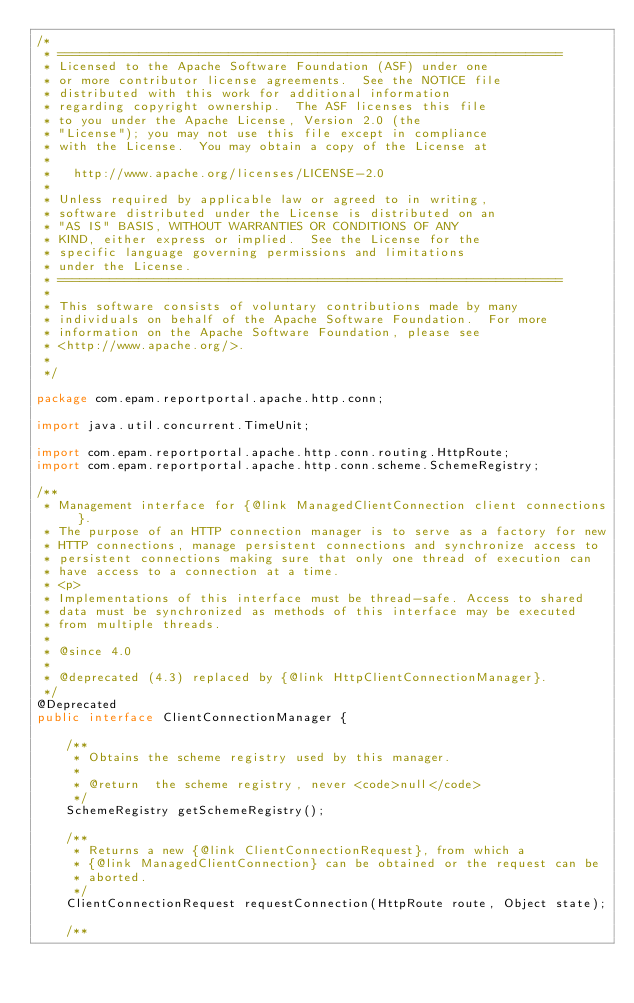Convert code to text. <code><loc_0><loc_0><loc_500><loc_500><_Java_>/*
 * ====================================================================
 * Licensed to the Apache Software Foundation (ASF) under one
 * or more contributor license agreements.  See the NOTICE file
 * distributed with this work for additional information
 * regarding copyright ownership.  The ASF licenses this file
 * to you under the Apache License, Version 2.0 (the
 * "License"); you may not use this file except in compliance
 * with the License.  You may obtain a copy of the License at
 *
 *   http://www.apache.org/licenses/LICENSE-2.0
 *
 * Unless required by applicable law or agreed to in writing,
 * software distributed under the License is distributed on an
 * "AS IS" BASIS, WITHOUT WARRANTIES OR CONDITIONS OF ANY
 * KIND, either express or implied.  See the License for the
 * specific language governing permissions and limitations
 * under the License.
 * ====================================================================
 *
 * This software consists of voluntary contributions made by many
 * individuals on behalf of the Apache Software Foundation.  For more
 * information on the Apache Software Foundation, please see
 * <http://www.apache.org/>.
 *
 */

package com.epam.reportportal.apache.http.conn;

import java.util.concurrent.TimeUnit;

import com.epam.reportportal.apache.http.conn.routing.HttpRoute;
import com.epam.reportportal.apache.http.conn.scheme.SchemeRegistry;

/**
 * Management interface for {@link ManagedClientConnection client connections}.
 * The purpose of an HTTP connection manager is to serve as a factory for new
 * HTTP connections, manage persistent connections and synchronize access to
 * persistent connections making sure that only one thread of execution can
 * have access to a connection at a time.
 * <p>
 * Implementations of this interface must be thread-safe. Access to shared
 * data must be synchronized as methods of this interface may be executed
 * from multiple threads.
 *
 * @since 4.0
 *
 * @deprecated (4.3) replaced by {@link HttpClientConnectionManager}.
 */
@Deprecated
public interface ClientConnectionManager {

    /**
     * Obtains the scheme registry used by this manager.
     *
     * @return  the scheme registry, never <code>null</code>
     */
    SchemeRegistry getSchemeRegistry();

    /**
     * Returns a new {@link ClientConnectionRequest}, from which a
     * {@link ManagedClientConnection} can be obtained or the request can be
     * aborted.
     */
    ClientConnectionRequest requestConnection(HttpRoute route, Object state);

    /**</code> 